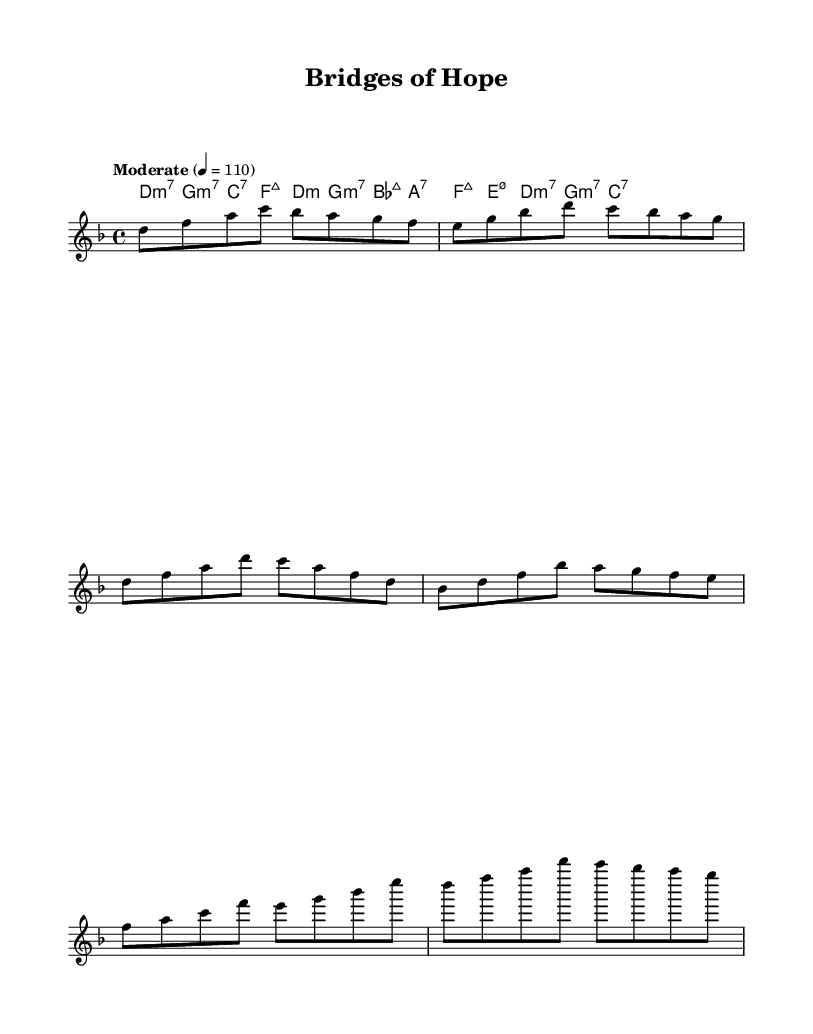What is the key signature of this music? The key signature is one flat, which indicates D minor.
Answer: D minor What is the time signature of this music? The time signature is indicated at the beginning of the score and shows that it is in 4/4.
Answer: 4/4 What is the tempo marking for this piece? The tempo marking in the score is "Moderate" with a metronome setting of 110 beats per minute, indicating a moderate speed.
Answer: Moderate 4 = 110 Which chord is played during the introductory section? The introductory section starts with the D minor 7 chord, as shown in the chord symbols above the melody.
Answer: D:m7 How many measures are there in the Chorus section? Counting the measures listed in the Chorus, we find there are four measures in total, reflecting the typical structure of a chorus in a song.
Answer: 4 What type of seventh chord is featured in the first measure? The chord in the first measure is D minor 7, which includes the root note, minor third, fifth, and minor seventh.
Answer: D:m7 How does the harmonic progression of the Chorus differ from the Verse? The Chorus follows a more extended harmonic progression with richer seventh chords, while the Verse features simpler triadic chords and fewer variations, creating a contrast.
Answer: More extended harmonic progression 